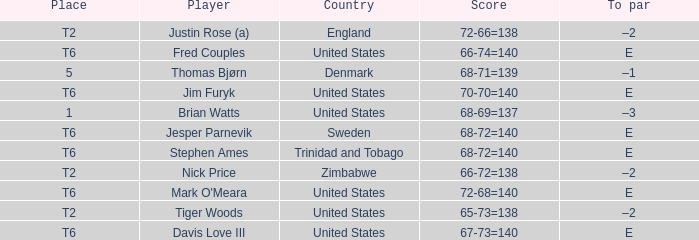What was the TO par for the player who scored 68-71=139? –1. 